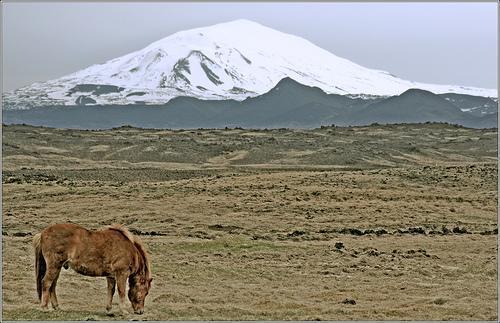How many animals are shown?
Give a very brief answer. 1. How many animals in the foreground?
Give a very brief answer. 1. 